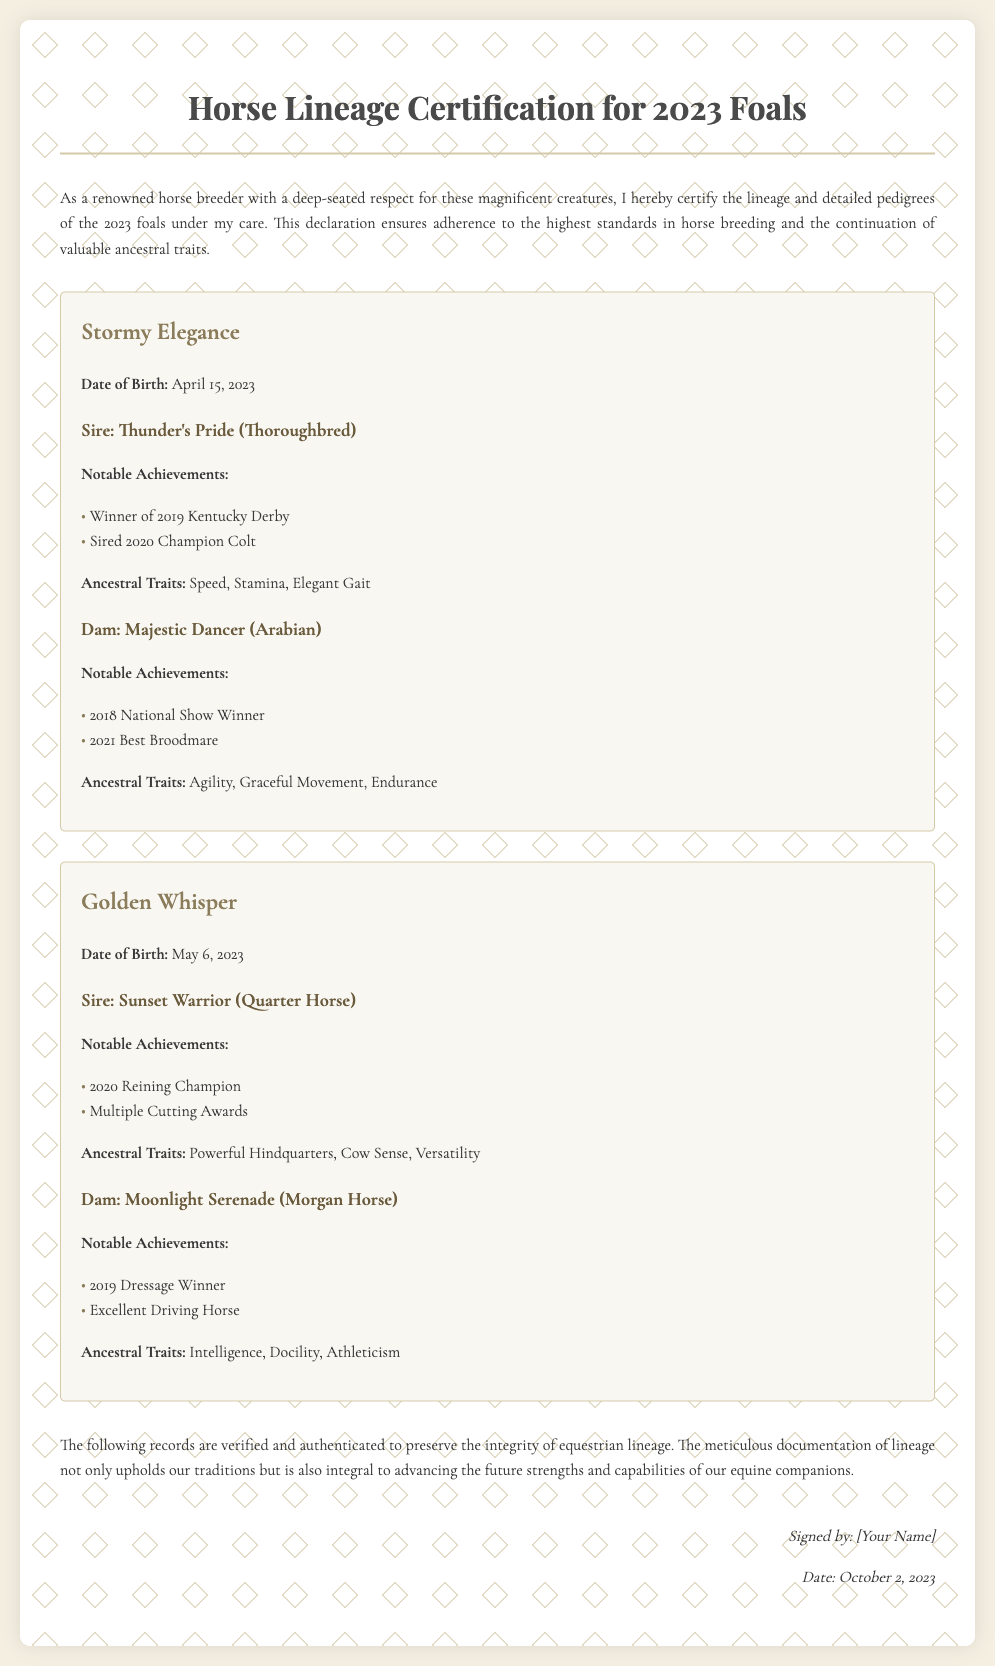What is the title of the document? The title appears prominently at the top of the document indicating its purpose.
Answer: Horse Lineage Certification for 2023 Foals Who is the sire of Stormy Elegance? The sire's name is mentioned under the details of Stormy Elegance, linking to its lineage.
Answer: Thunder's Pride What is the date of birth of Golden Whisper? The date of birth is specified clearly in the section dedicated to Golden Whisper.
Answer: May 6, 2023 What notable achievement did Thunder's Pride accomplish? One of Thunder's Pride's achievements is highlighted in the document under notable accomplishments.
Answer: Winner of 2019 Kentucky Derby What ancestral trait is associated with Moonlight Serenade? Ancestral traits for each dam are listed in their respective sections, indicating their characteristics.
Answer: Intelligence What is the type of the dam for Stormy Elegance? The type of the dam is noted in the document, distinguishing her breed.
Answer: Arabian How many notable achievements are listed for Sunset Warrior? The number of notable achievements under Sunset Warrior is counted from the document's details.
Answer: Two What month and year was the document signed? The document specifies the signature date, which concludes the details with a clear timestamp.
Answer: October 2023 What is the main purpose of this certification? The introduction outlines the purpose of the certification, summarizing its intent.
Answer: Certification of lineage and detailed pedigrees 